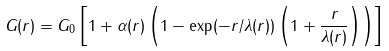Convert formula to latex. <formula><loc_0><loc_0><loc_500><loc_500>G ( r ) = G _ { 0 } \left [ 1 + \alpha ( r ) \left ( 1 - \exp ( - r / \lambda ( r ) ) \left ( 1 + \frac { r } { \lambda ( r ) } \right ) \right ) \right ]</formula> 